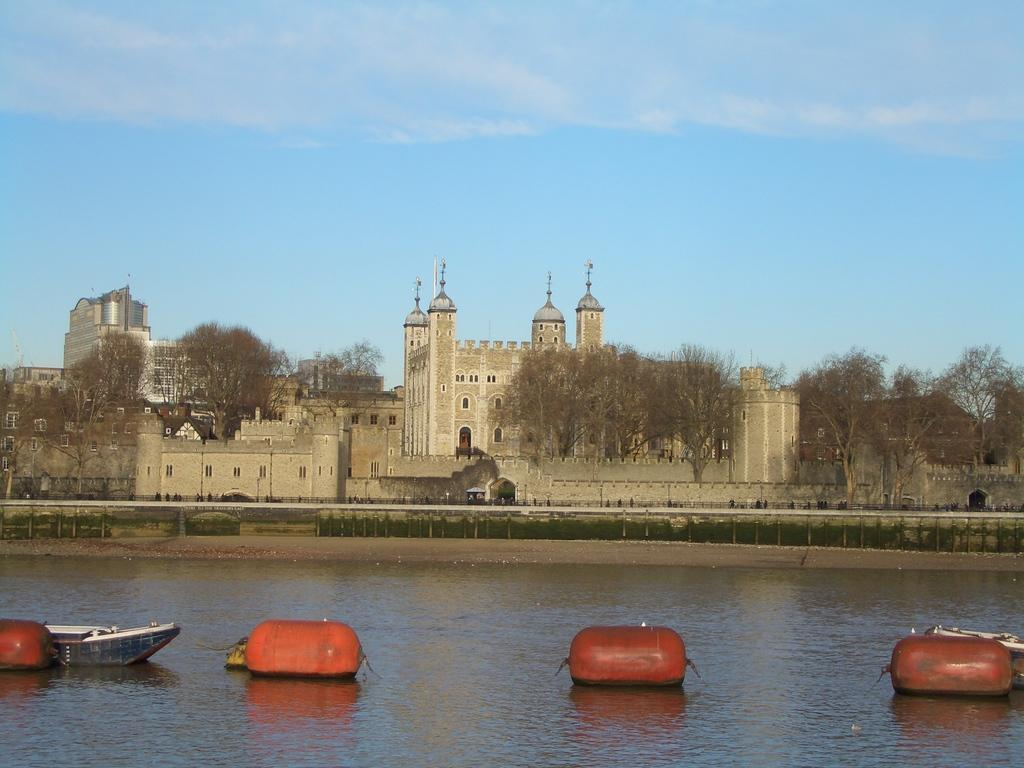What is the primary element visible in the image? There is water in the image. What color are the objects in the image? There are red-colored objects in the image. What type of vehicle is present in the image? There is a boat in the image. What can be seen in the distance in the image? There are buildings and trees in the background of the image, and the sky is clear. What is the value of the parent sailing in the image? There is no parent or sailing activity present in the image; it features water, red-colored objects, a boat, and a background with buildings, trees, and a clear sky. 